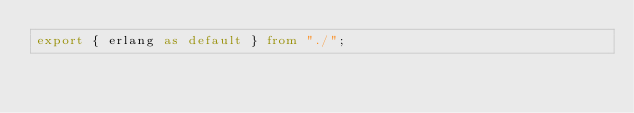<code> <loc_0><loc_0><loc_500><loc_500><_TypeScript_>export { erlang as default } from "./";
</code> 